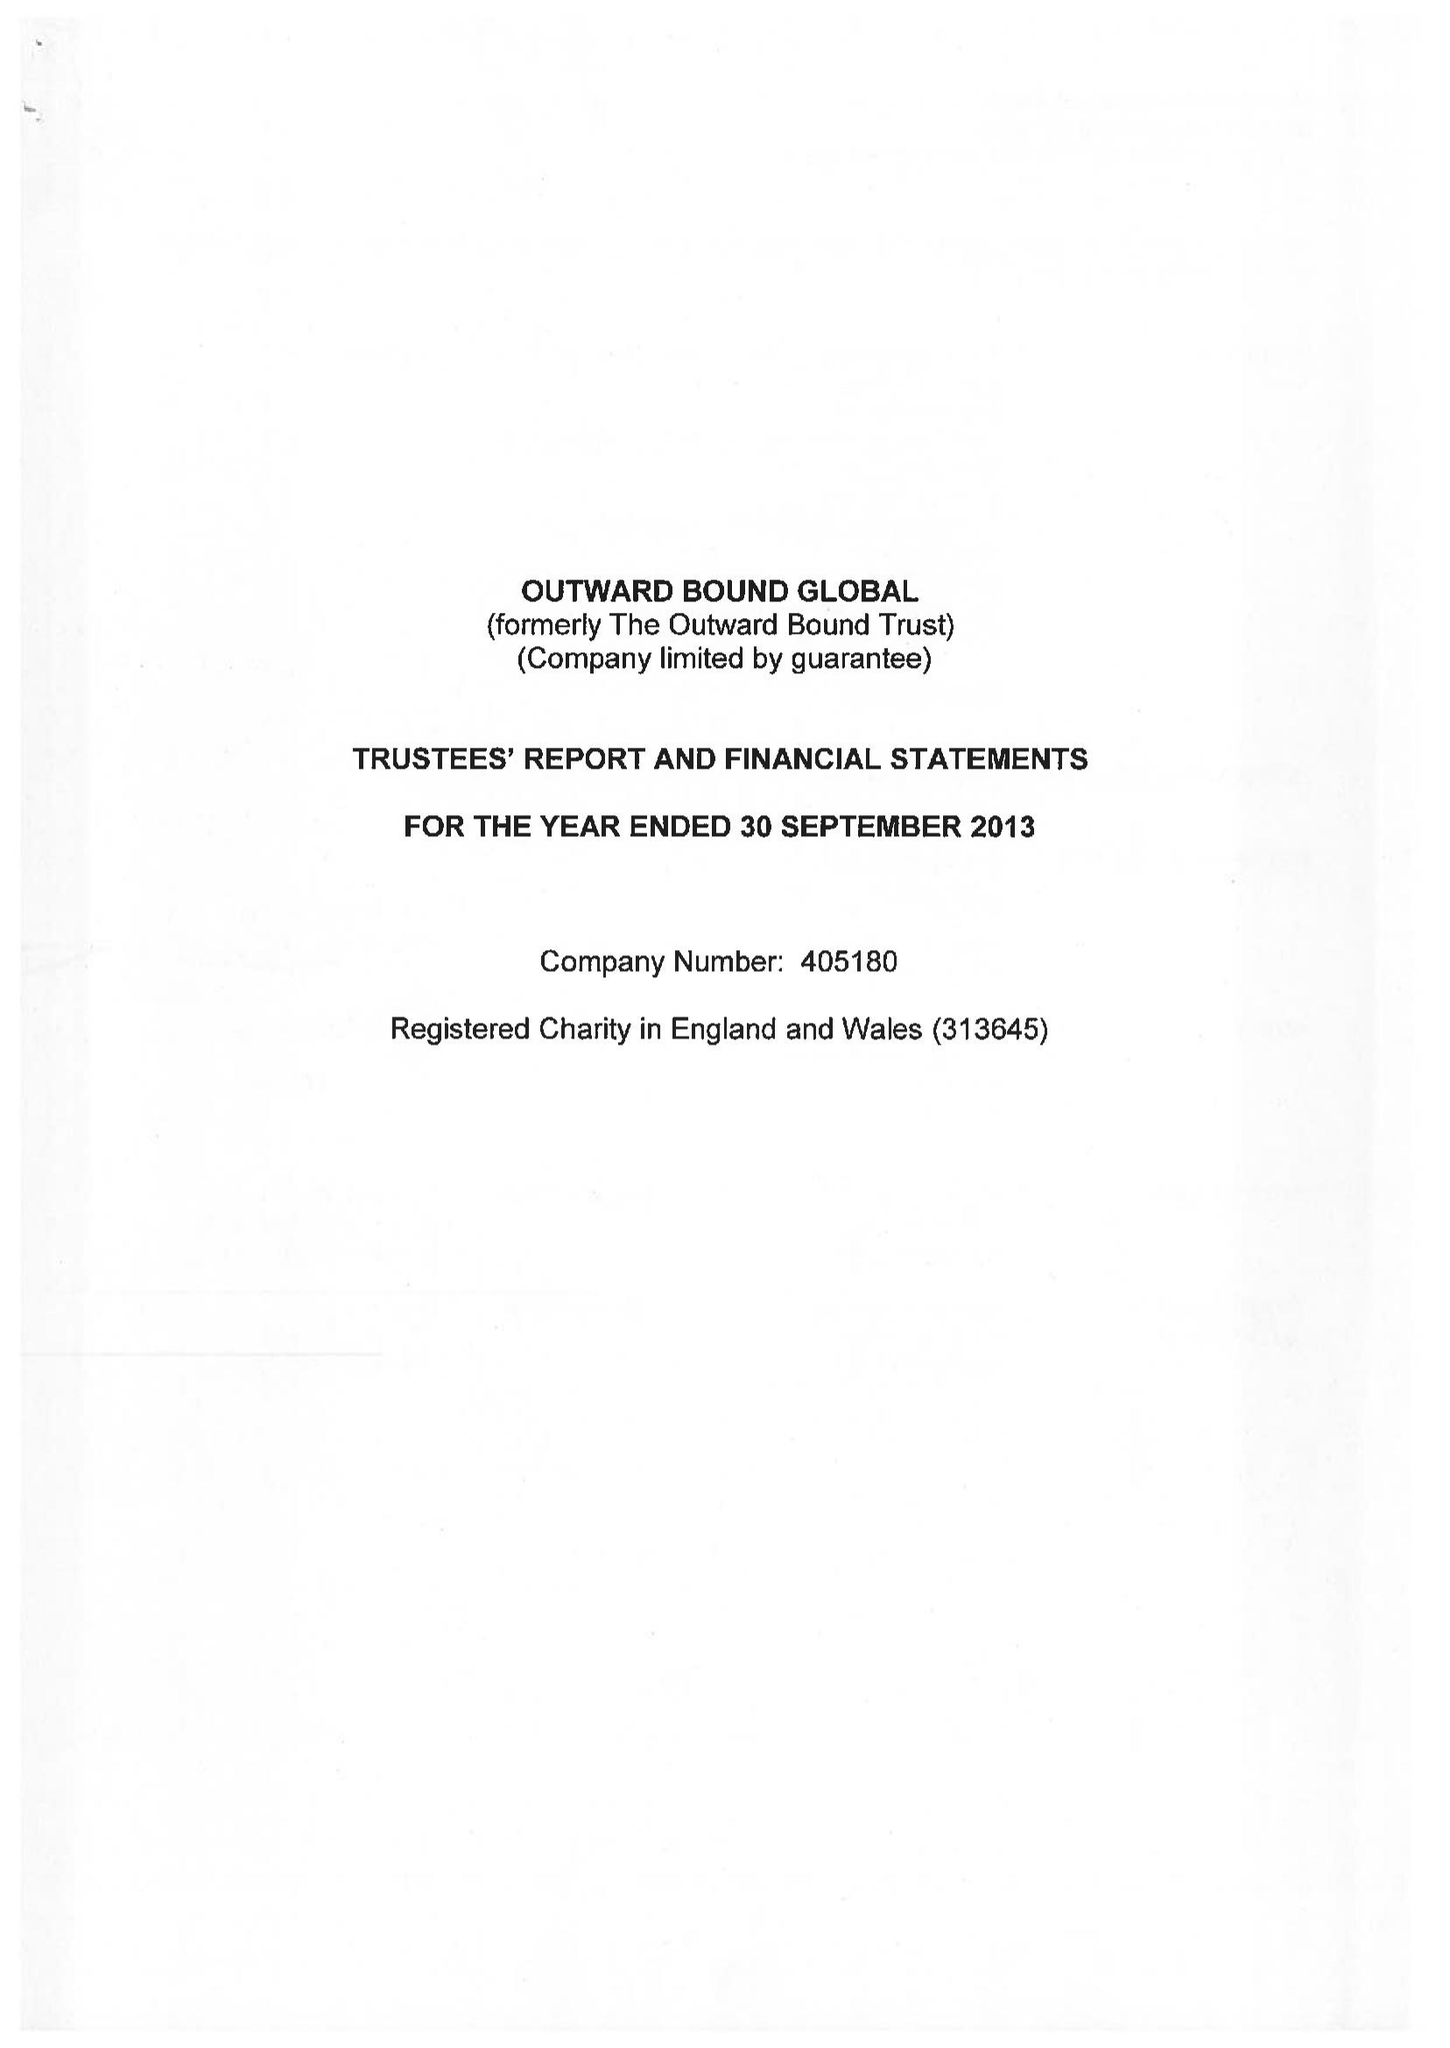What is the value for the address__postcode?
Answer the question using a single word or phrase. CA10 2HX 